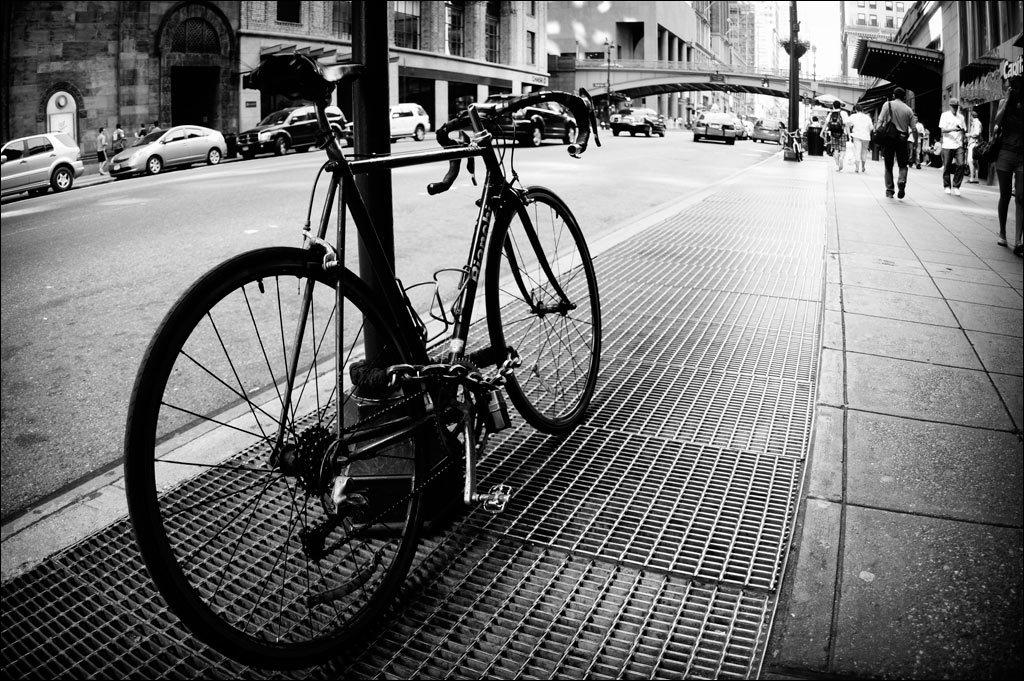What is the color scheme of the image? The image is black and white. What mode of transportation can be seen in the image? There is a bicycle in the image. What type of vehicles are present in the image? There are cars in the image. What structures can be seen in the image? There are poles and a bridge in the image. Are there any human figures in the image? Yes, there are people in the image. What can be seen in the background of the image? There are buildings in the background of the image. How many chairs are visible in the image? There are no chairs present in the image. What type of button is being pressed by the person in the image? There are no buttons or people pressing buttons in the image. 